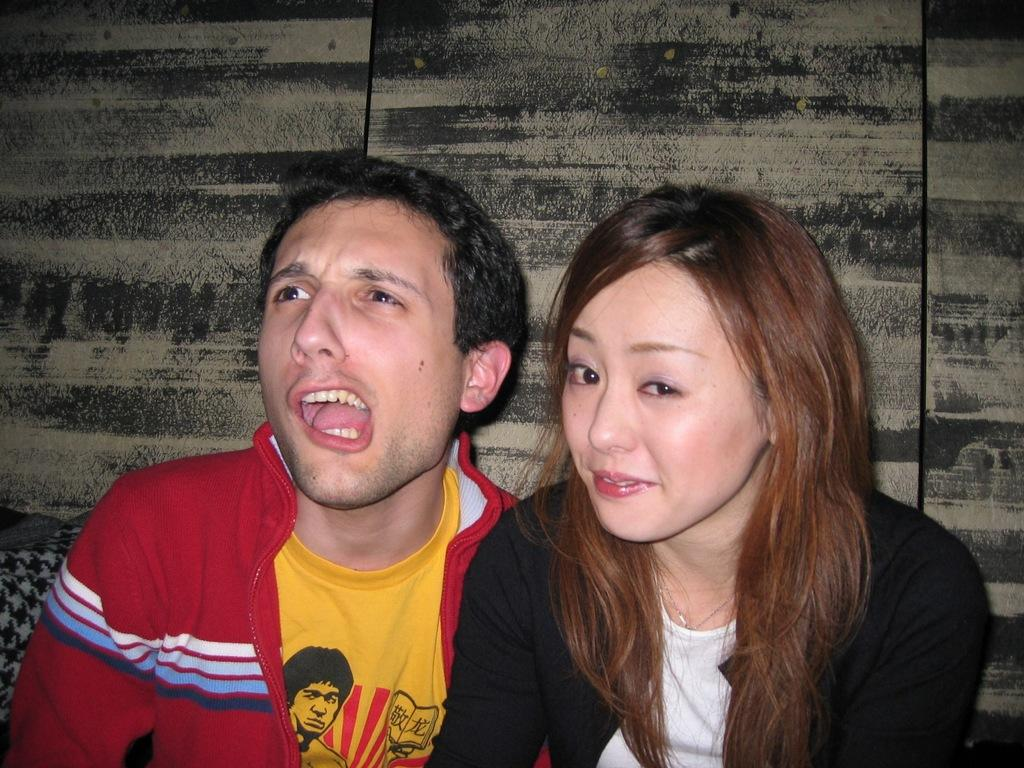Who can be seen in the image? There is a man and a woman in the image. What are the man and woman doing in the image? The man and woman are sitting. What type of material might be present in the image? The image appears to show a wooden board and there is an object that might be a cloth in the image. What type of beast can be seen in the image? There is no beast present in the image; it features a man and a woman sitting with a wooden board and a possible cloth. Is there a scarf visible in the image? The image does not show a scarf; it only shows a possible cloth. 